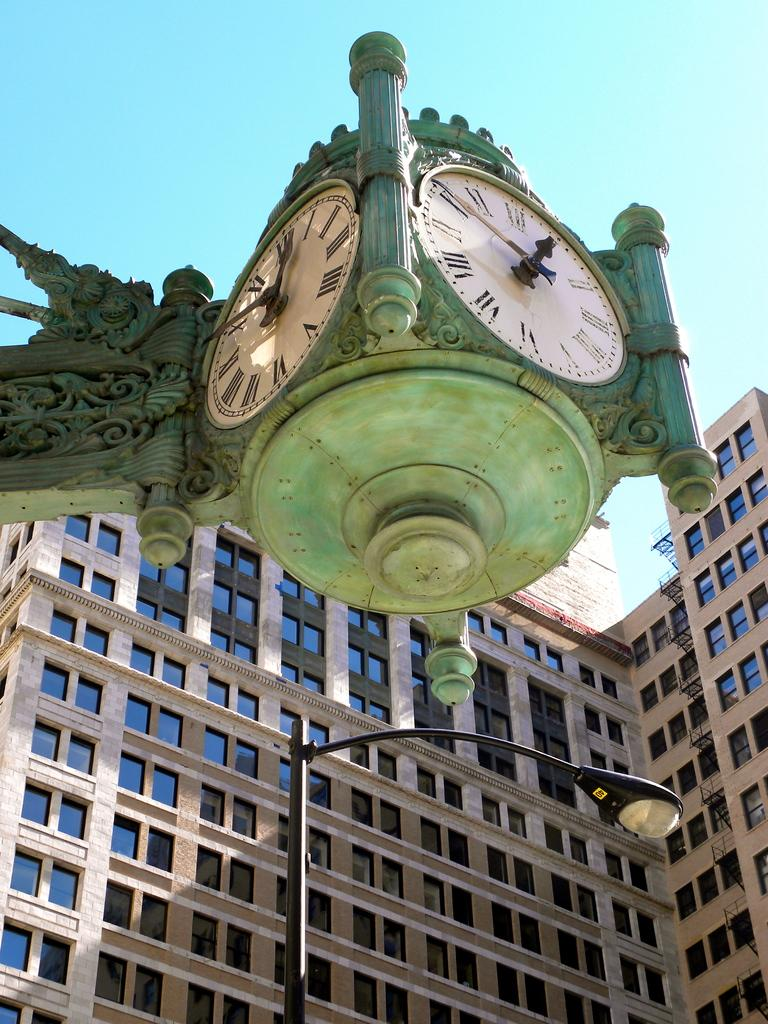Provide a one-sentence caption for the provided image. The current time in this town is approximately 12:50. 